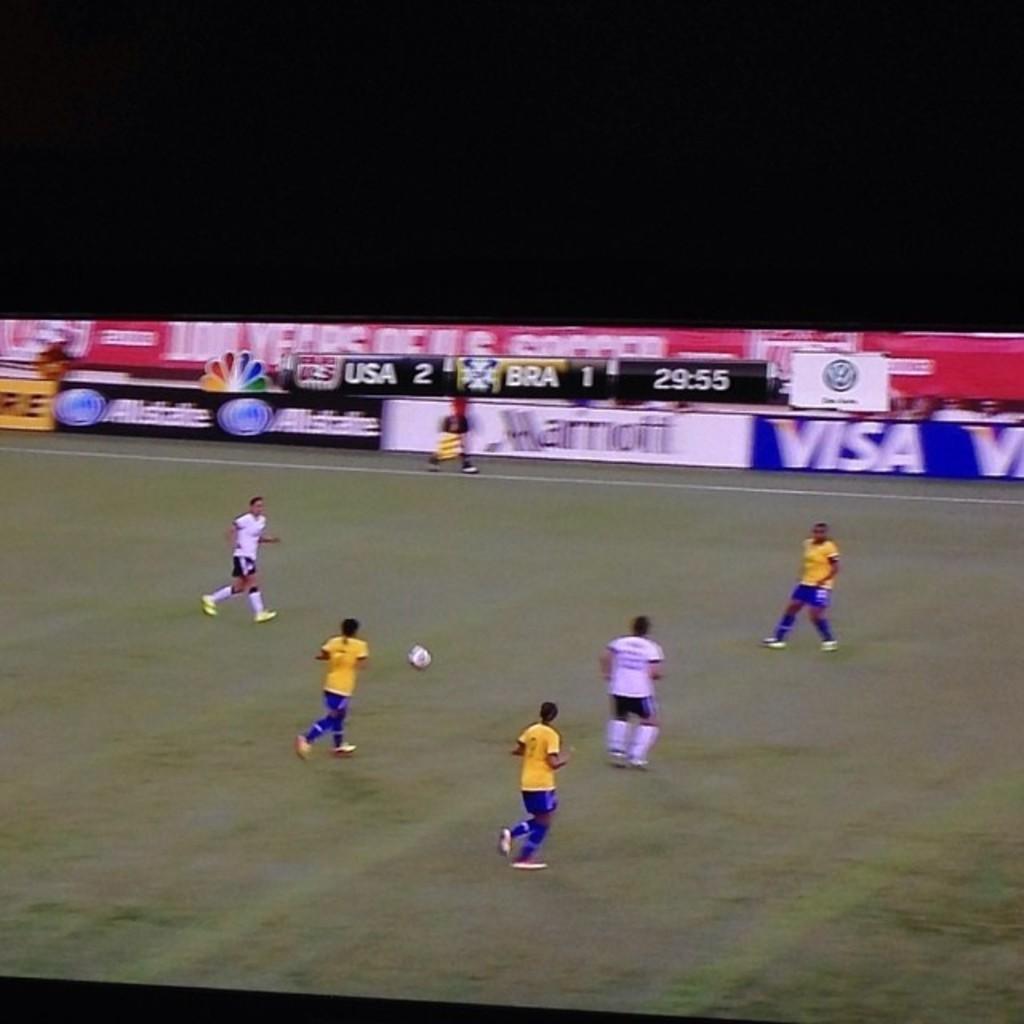How would you summarize this image in a sentence or two? This is a playing ground. Here I can see five men are wearing t-shirts, shorts and playing the football. The ball is placed on the ground. In the background, I can see a person is walking. At the back there is a board. 